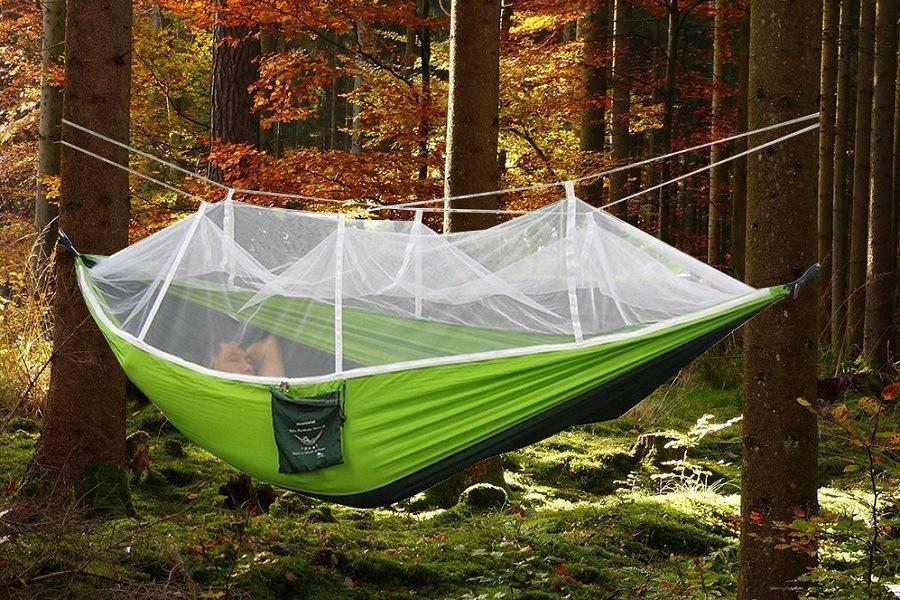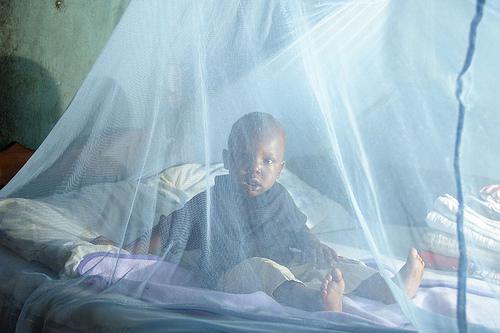The first image is the image on the left, the second image is the image on the right. Examine the images to the left and right. Is the description "An image shows a dark-skinned human baby surrounded by netting." accurate? Answer yes or no. Yes. The first image is the image on the left, the second image is the image on the right. Evaluate the accuracy of this statement regarding the images: "A net is set up over a bed in one of the images.". Is it true? Answer yes or no. Yes. 